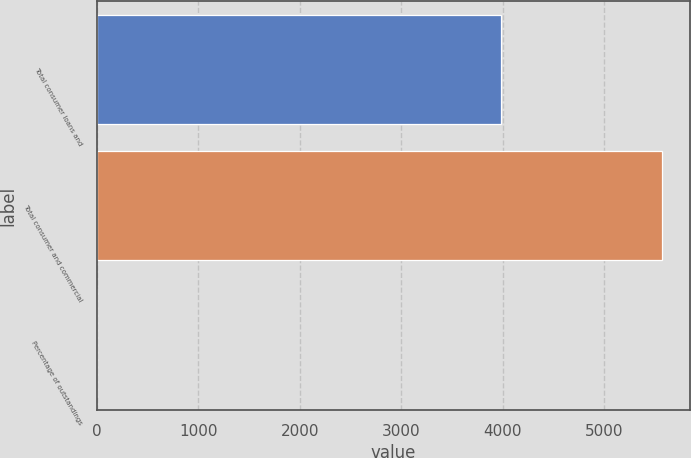Convert chart to OTSL. <chart><loc_0><loc_0><loc_500><loc_500><bar_chart><fcel>Total consumer loans and<fcel>Total consumer and commercial<fcel>Percentage of outstandings<nl><fcel>3984<fcel>5567<fcel>0.61<nl></chart> 